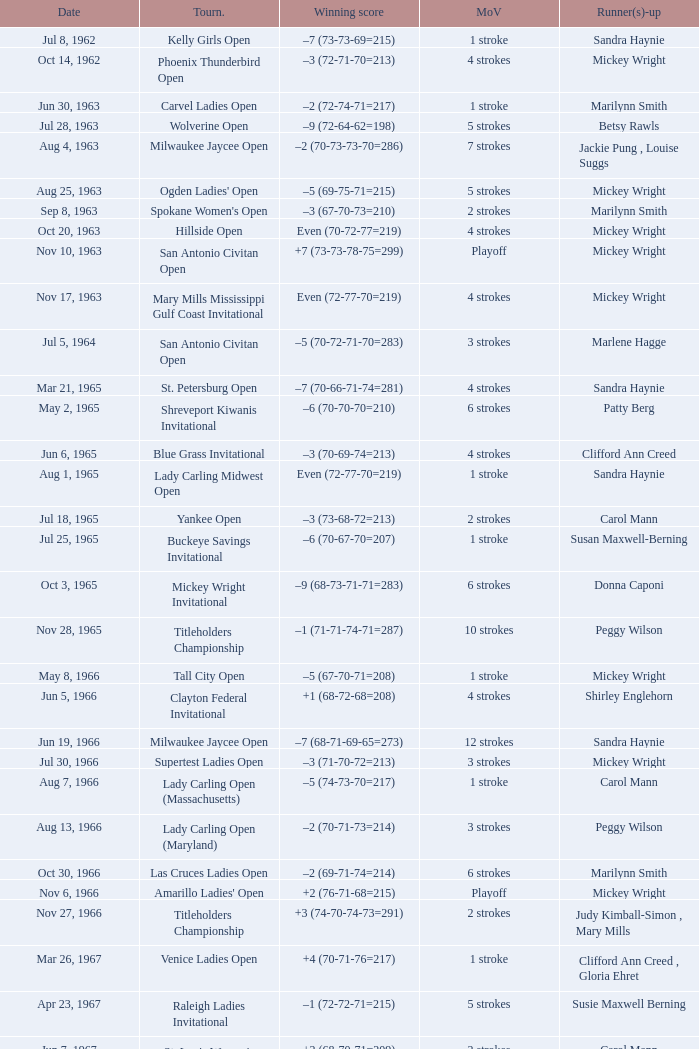What was the margin of victory on Apr 23, 1967? 5 strokes. 